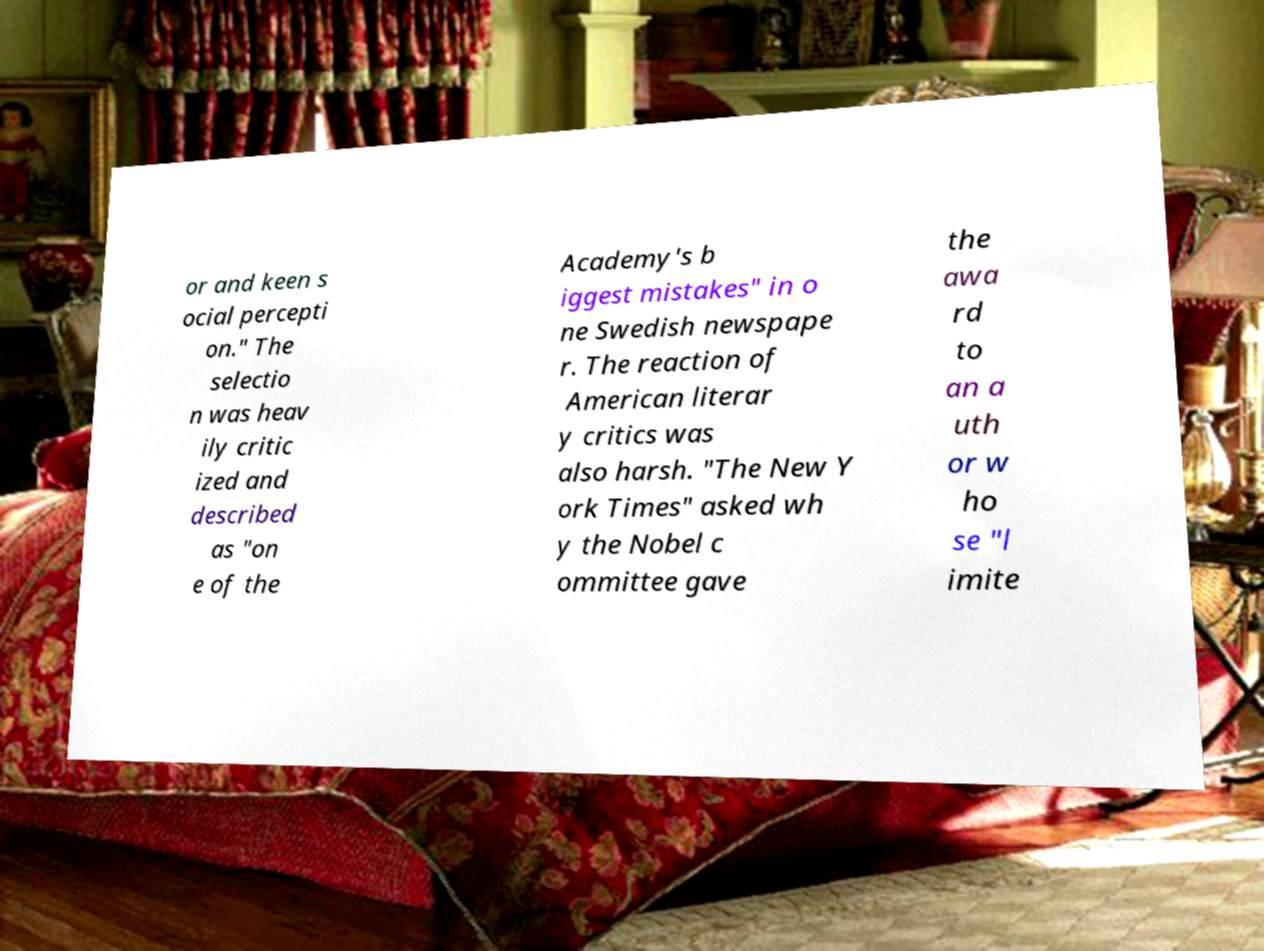Can you accurately transcribe the text from the provided image for me? or and keen s ocial percepti on." The selectio n was heav ily critic ized and described as "on e of the Academy's b iggest mistakes" in o ne Swedish newspape r. The reaction of American literar y critics was also harsh. "The New Y ork Times" asked wh y the Nobel c ommittee gave the awa rd to an a uth or w ho se "l imite 